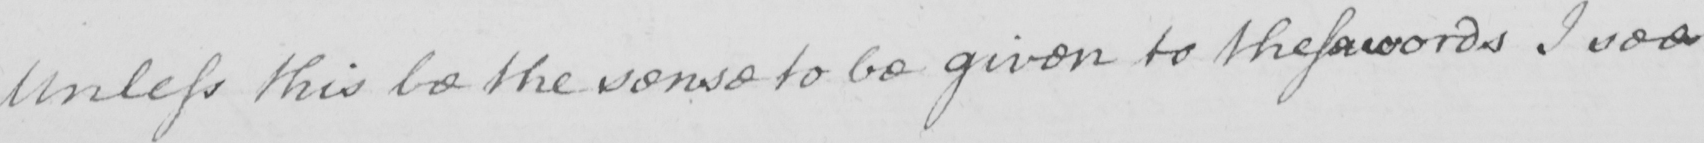What is written in this line of handwriting? Unless this be the sense to be given to these words I see 